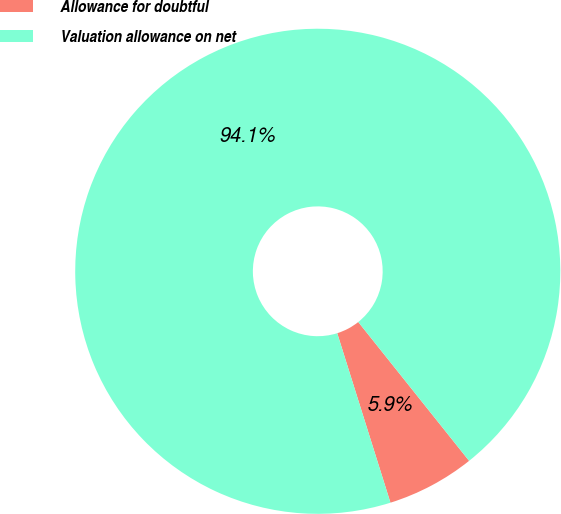<chart> <loc_0><loc_0><loc_500><loc_500><pie_chart><fcel>Allowance for doubtful<fcel>Valuation allowance on net<nl><fcel>5.88%<fcel>94.12%<nl></chart> 